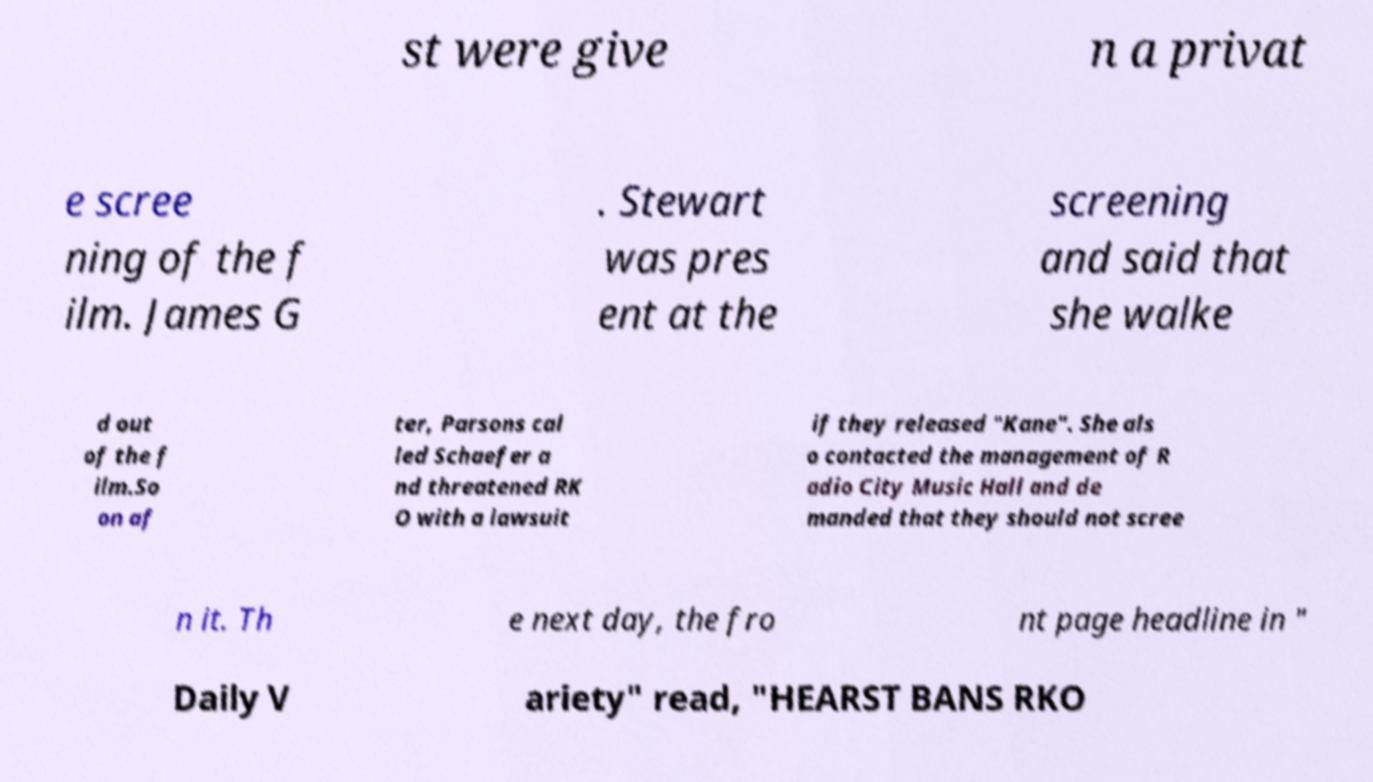There's text embedded in this image that I need extracted. Can you transcribe it verbatim? st were give n a privat e scree ning of the f ilm. James G . Stewart was pres ent at the screening and said that she walke d out of the f ilm.So on af ter, Parsons cal led Schaefer a nd threatened RK O with a lawsuit if they released "Kane". She als o contacted the management of R adio City Music Hall and de manded that they should not scree n it. Th e next day, the fro nt page headline in " Daily V ariety" read, "HEARST BANS RKO 